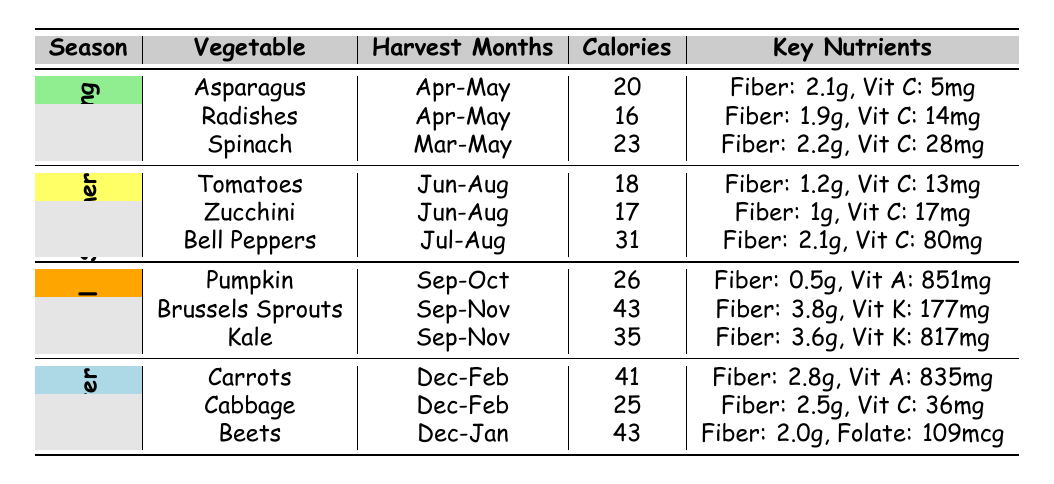What vegetables are available in the Fall season? According to the table, the vegetables available in the Fall season are Pumpkin, Brussels Sprouts, and Kale.
Answer: Pumpkin, Brussels Sprouts, Kale Which vegetable has the highest calories in the Summer? The table lists the calories for each vegetable in the Summer: Tomatoes (18), Zucchini (17), and Bell Peppers (31). The highest calorie vegetable is Bell Peppers with 31 calories.
Answer: Bell Peppers Are Radishes available in the Winter? The table shows that Radishes are listed under the Spring season with harvest months in April and May. Therefore, Radishes are not available in the Winter.
Answer: No What is the total calorie count for the vegetables available in Spring? In Spring, the calorie counts for the vegetables are Asparagus (20), Radishes (16), and Spinach (23). The total is calculated as: 20 + 16 + 23 = 59.
Answer: 59 Which vegetable contains the most Vitamin C? From the table, Spinach has the highest Vitamin C content with 28 mg compared to Radishes (14 mg) and Cabbage (36 mg). The highest is Cabbage at 36 mg.
Answer: Cabbage Is it true that all vegetables in Winter are available in December? The table indicates that Carrots, Cabbage, and Beets can be harvested in December. Hence, it is true that all Winter vegetables are available in December.
Answer: Yes What vegetable offers the highest fiber content in the Fall? The fiber content for the Fall vegetables is: Pumpkin (0.5g), Brussels Sprouts (3.8g), and Kale (3.6g). The vegetable with the highest fiber content is Brussels Sprouts at 3.8g.
Answer: Brussels Sprouts How many vegetables are available in Summer and what is their average calorie count? In Summer, there are three vegetables: Tomatoes (18), Zucchini (17), and Bell Peppers (31). The average can be calculated as: (18 + 17 + 31) / 3 = 22.
Answer: 22 What is the most calorie-dense vegetable in the Winter? The calorie counts for Winter vegetables are Carrots (41), Cabbage (25), and Beets (43). The most calorie-dense vegetable is Beets with 43 calories.
Answer: Beets 